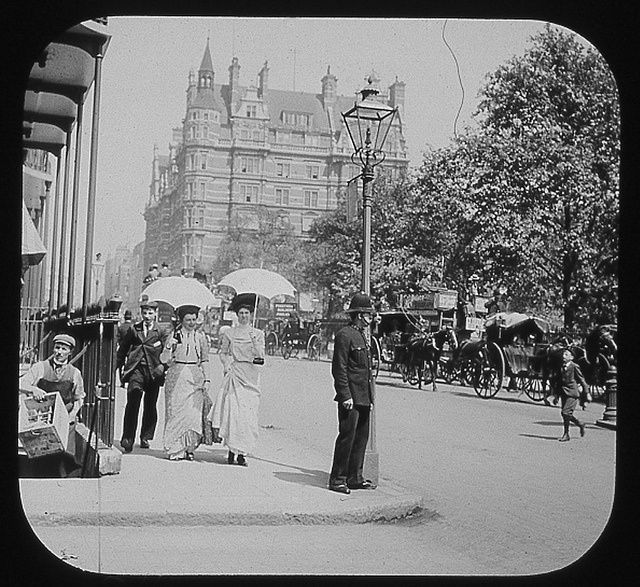Describe the objects in this image and their specific colors. I can see people in black, darkgray, lightgray, and gray tones, people in black, gray, darkgray, and gainsboro tones, people in black, darkgray, lightgray, and gray tones, people in black, gray, darkgray, and lightgray tones, and people in black, darkgray, gray, and lightgray tones in this image. 